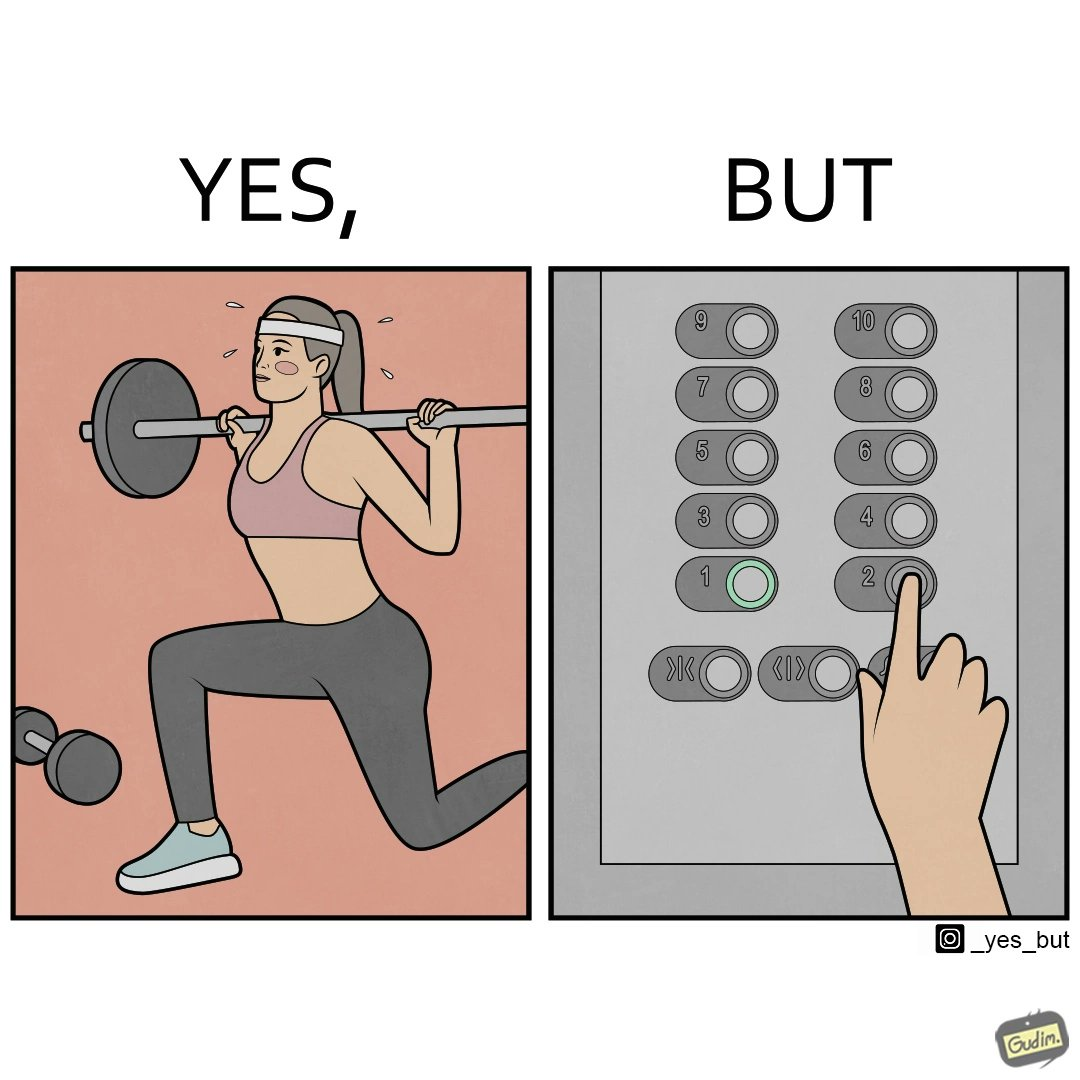Why is this image considered satirical? The image is satirical because it shows that while people do various kinds of exercises and go to gym to stay fit, they avoid doing simplest of physical tasks like using stairs instead of elevators to get to even the first or the second floor of a building. 